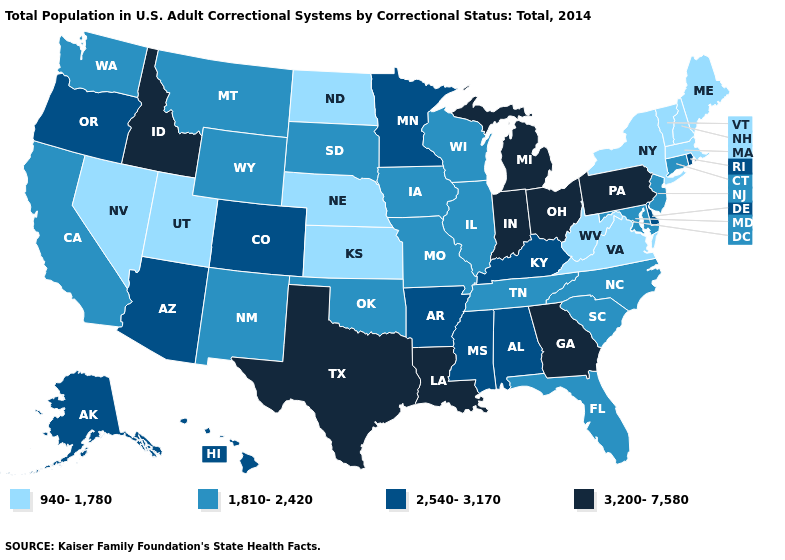Among the states that border North Carolina , which have the lowest value?
Answer briefly. Virginia. Does the map have missing data?
Give a very brief answer. No. Does Nevada have a lower value than Wyoming?
Quick response, please. Yes. Which states have the lowest value in the South?
Write a very short answer. Virginia, West Virginia. Name the states that have a value in the range 2,540-3,170?
Keep it brief. Alabama, Alaska, Arizona, Arkansas, Colorado, Delaware, Hawaii, Kentucky, Minnesota, Mississippi, Oregon, Rhode Island. Among the states that border Nevada , which have the lowest value?
Quick response, please. Utah. Is the legend a continuous bar?
Keep it brief. No. Name the states that have a value in the range 2,540-3,170?
Answer briefly. Alabama, Alaska, Arizona, Arkansas, Colorado, Delaware, Hawaii, Kentucky, Minnesota, Mississippi, Oregon, Rhode Island. What is the value of Montana?
Short answer required. 1,810-2,420. What is the value of New York?
Short answer required. 940-1,780. Does the first symbol in the legend represent the smallest category?
Keep it brief. Yes. What is the value of North Dakota?
Give a very brief answer. 940-1,780. Which states have the lowest value in the USA?
Answer briefly. Kansas, Maine, Massachusetts, Nebraska, Nevada, New Hampshire, New York, North Dakota, Utah, Vermont, Virginia, West Virginia. Name the states that have a value in the range 940-1,780?
Concise answer only. Kansas, Maine, Massachusetts, Nebraska, Nevada, New Hampshire, New York, North Dakota, Utah, Vermont, Virginia, West Virginia. Does Indiana have the highest value in the USA?
Concise answer only. Yes. 